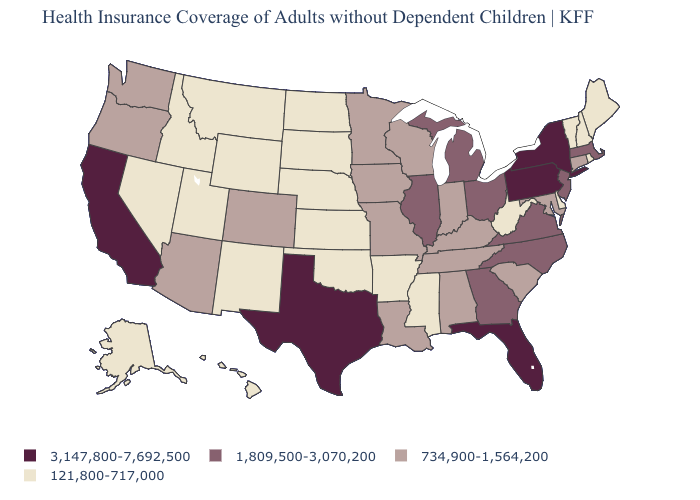Name the states that have a value in the range 1,809,500-3,070,200?
Short answer required. Georgia, Illinois, Massachusetts, Michigan, New Jersey, North Carolina, Ohio, Virginia. Name the states that have a value in the range 3,147,800-7,692,500?
Concise answer only. California, Florida, New York, Pennsylvania, Texas. Does South Carolina have the same value as Wisconsin?
Short answer required. Yes. What is the value of West Virginia?
Keep it brief. 121,800-717,000. Does California have the lowest value in the USA?
Concise answer only. No. Does Kentucky have the lowest value in the South?
Quick response, please. No. Name the states that have a value in the range 3,147,800-7,692,500?
Quick response, please. California, Florida, New York, Pennsylvania, Texas. What is the value of Washington?
Short answer required. 734,900-1,564,200. Does the map have missing data?
Quick response, please. No. Does South Dakota have the lowest value in the USA?
Keep it brief. Yes. What is the value of Wisconsin?
Keep it brief. 734,900-1,564,200. Name the states that have a value in the range 1,809,500-3,070,200?
Short answer required. Georgia, Illinois, Massachusetts, Michigan, New Jersey, North Carolina, Ohio, Virginia. Name the states that have a value in the range 3,147,800-7,692,500?
Concise answer only. California, Florida, New York, Pennsylvania, Texas. Does Colorado have the highest value in the USA?
Concise answer only. No. Name the states that have a value in the range 1,809,500-3,070,200?
Concise answer only. Georgia, Illinois, Massachusetts, Michigan, New Jersey, North Carolina, Ohio, Virginia. 